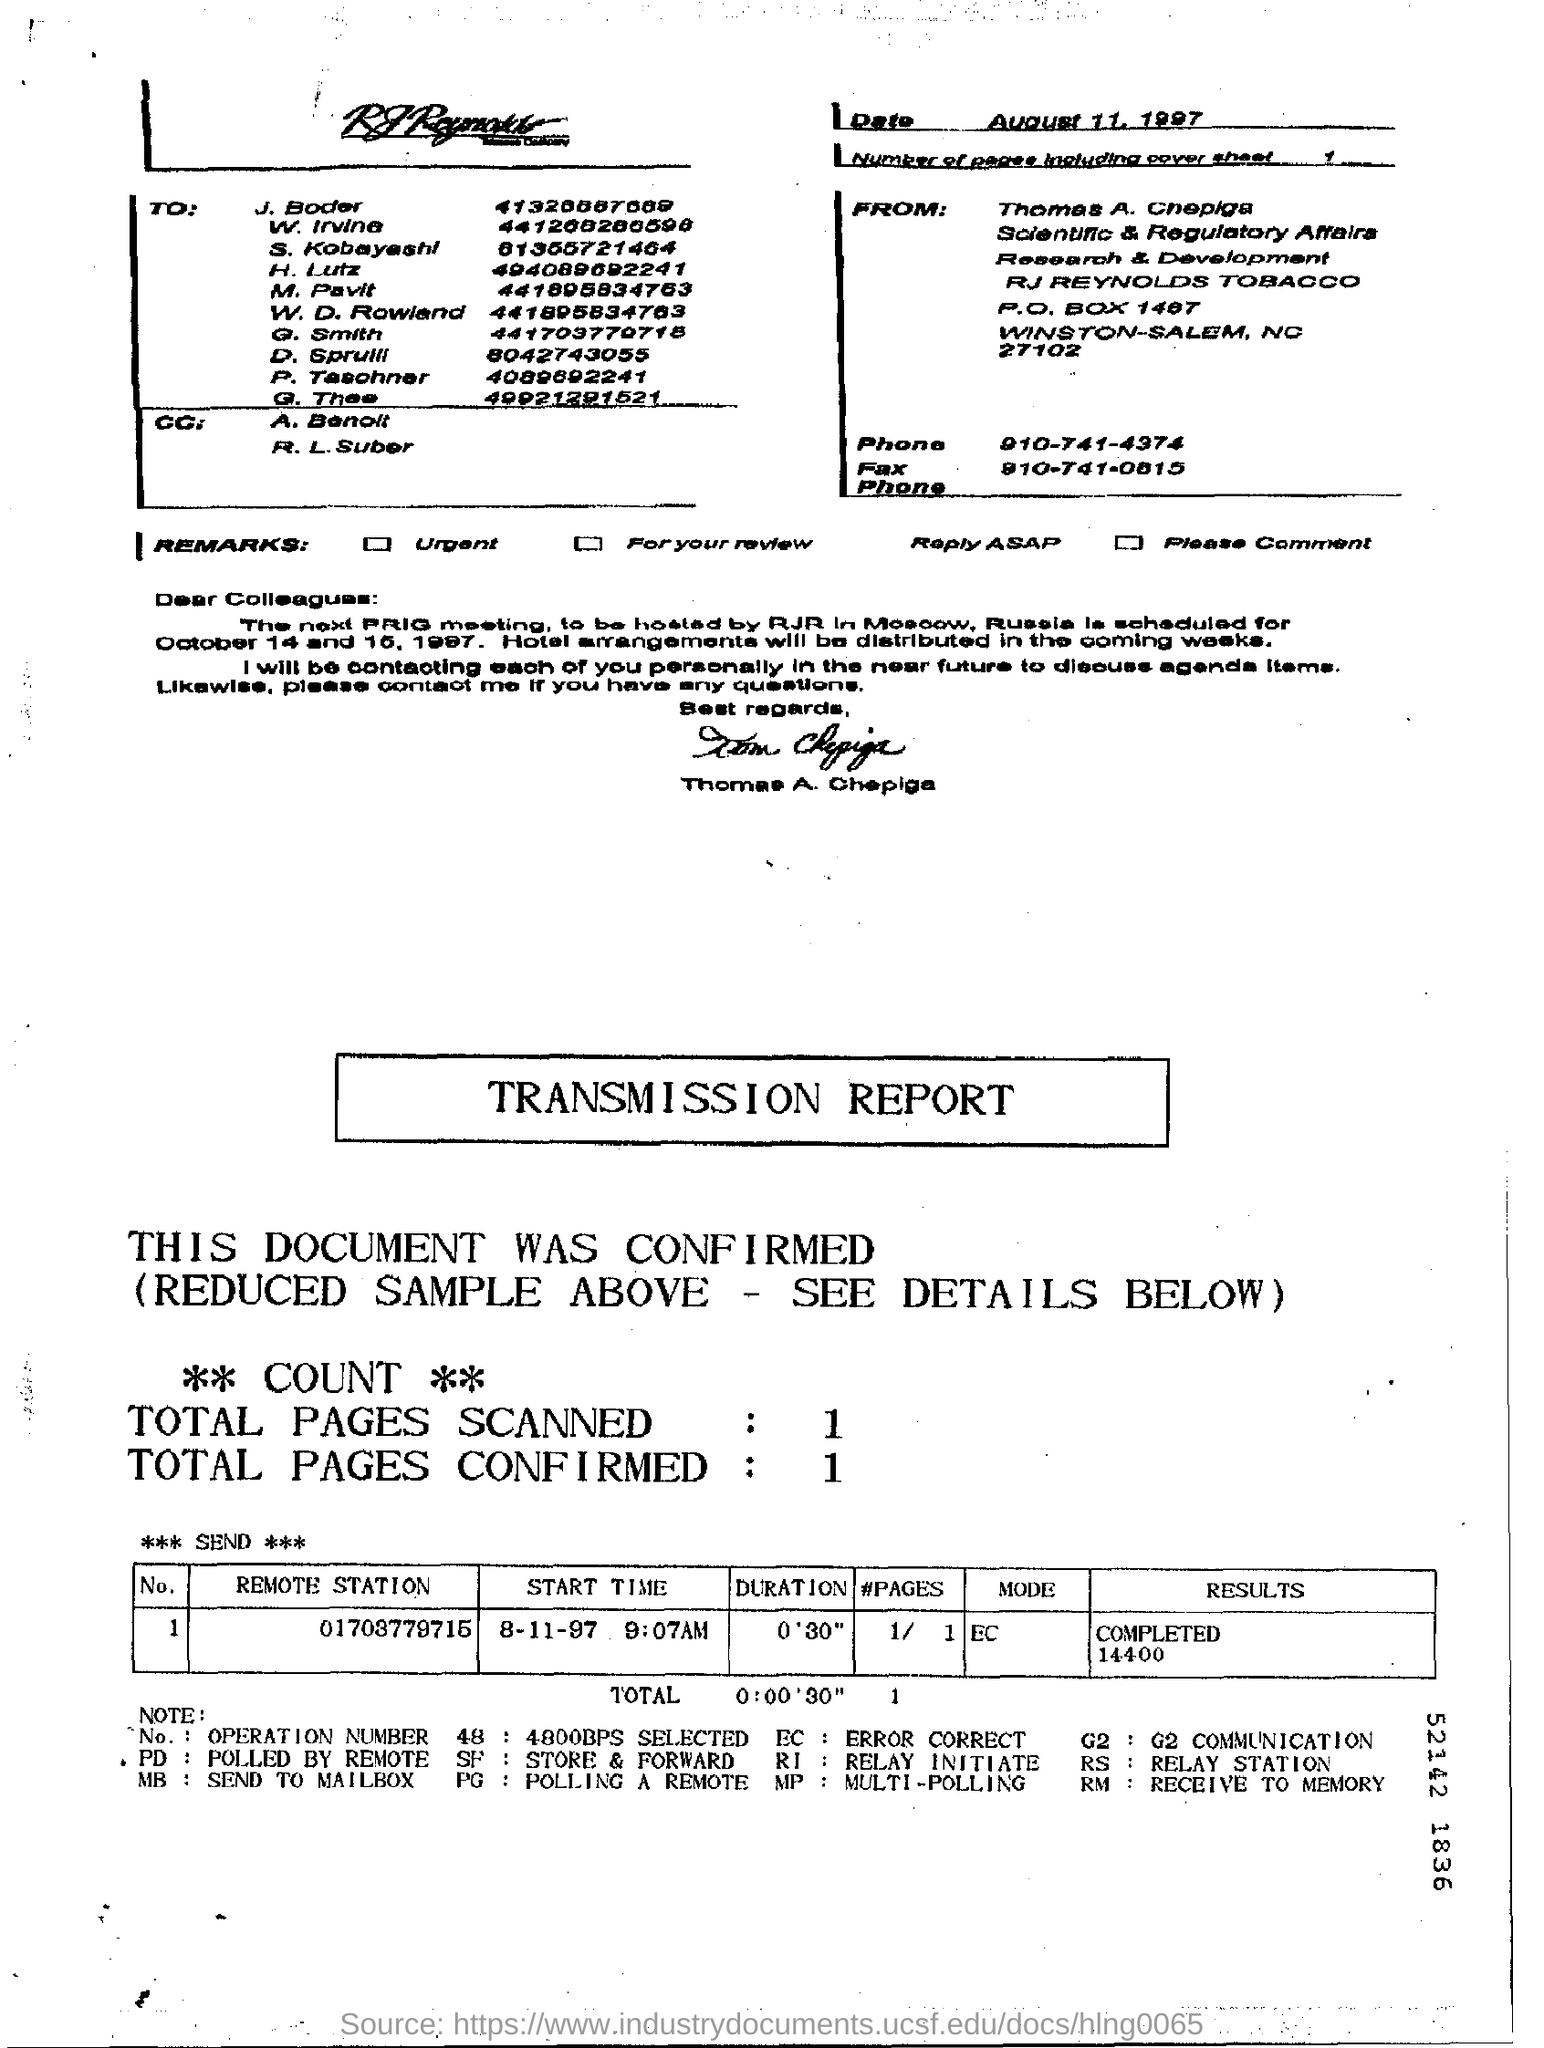Outline some significant characteristics in this image. The total number of pages scanned is 1.. The total number of pages confirmed is 1.. The results for the "Remote Station" 01703779715 are 14,400. What is the mode for the remote station number 01703779715?" is a question asking for information about the communication system. The date on the fax is August 11, 1997. 